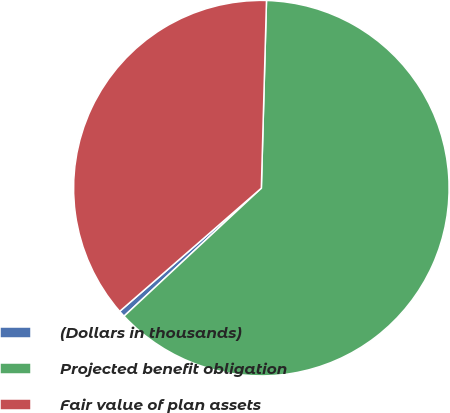Convert chart to OTSL. <chart><loc_0><loc_0><loc_500><loc_500><pie_chart><fcel>(Dollars in thousands)<fcel>Projected benefit obligation<fcel>Fair value of plan assets<nl><fcel>0.55%<fcel>62.62%<fcel>36.83%<nl></chart> 